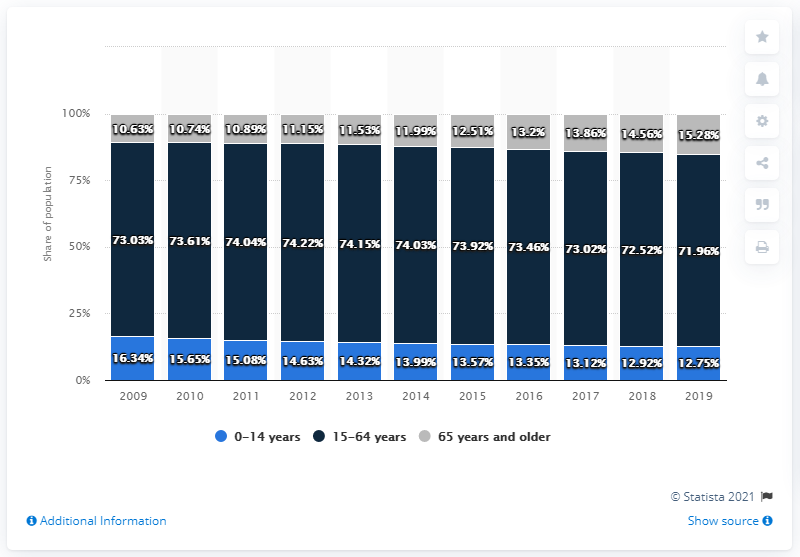Mention a couple of crucial points in this snapshot. In 2015, 15.28% of the population was 65 years and older, and by 2019, that percentage had increased to 17.12%. In 2019, approximately 15.28% of the population was 65 years and older. In 2019, 71.96% of the Taiwanese population was between the ages of 15 and 64. 